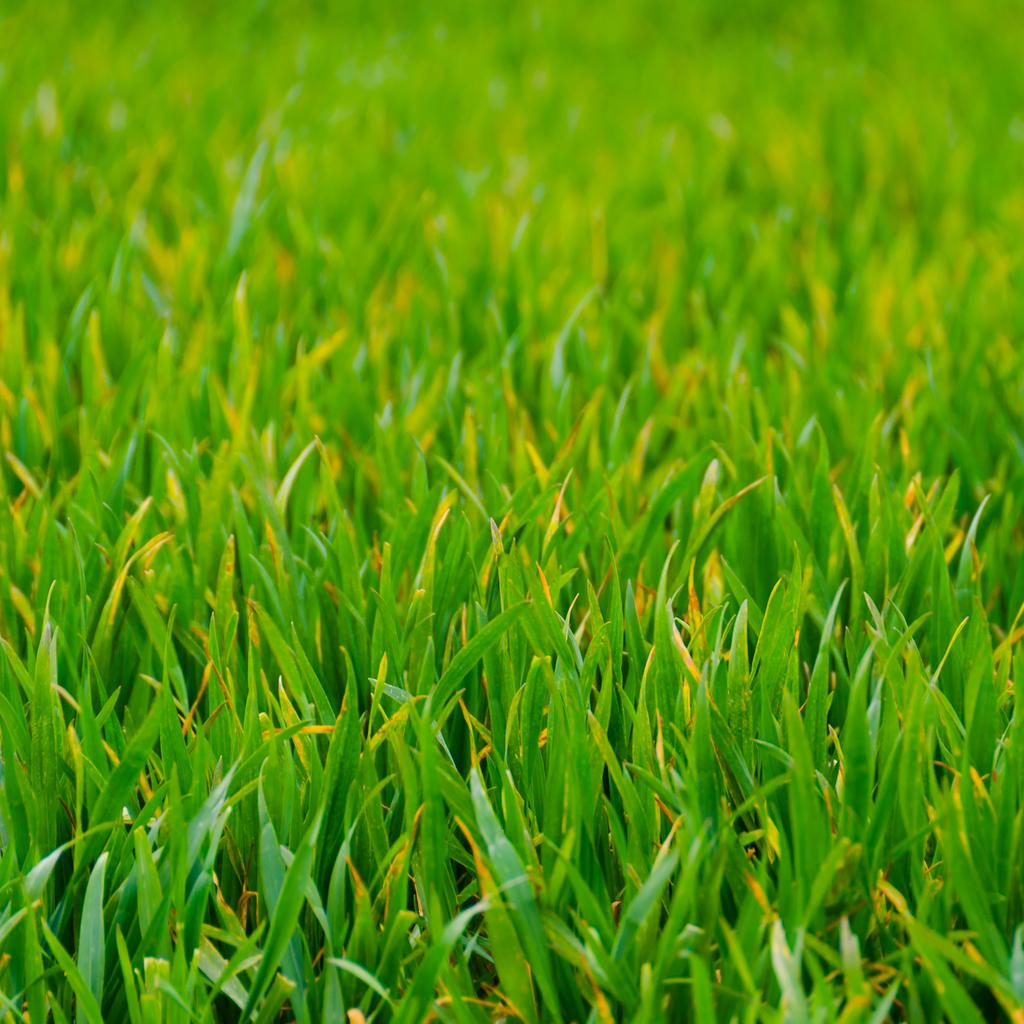What type of vegetation is visible in the foreground of the image? There is grass in the foreground of the image. What type of organization is responsible for the stove in the image? There is no stove present in the image, so it is not possible to determine which organization might be responsible for one. 